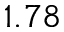Convert formula to latex. <formula><loc_0><loc_0><loc_500><loc_500>1 . 7 8</formula> 